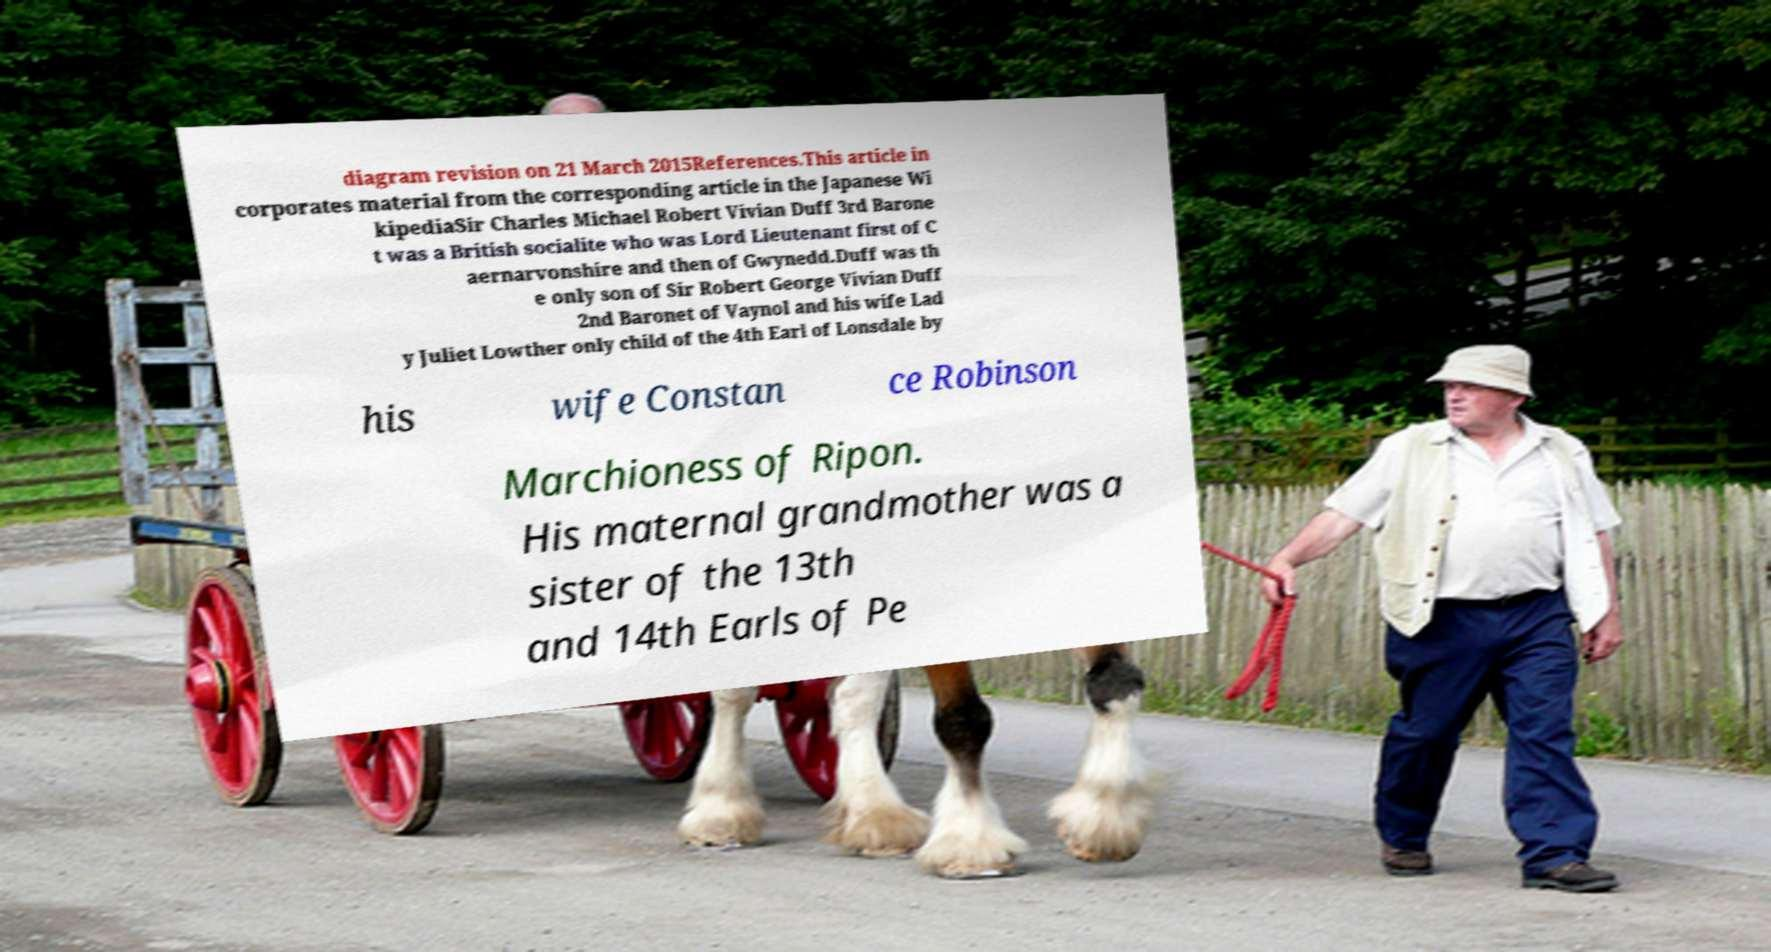I need the written content from this picture converted into text. Can you do that? diagram revision on 21 March 2015References.This article in corporates material from the corresponding article in the Japanese Wi kipediaSir Charles Michael Robert Vivian Duff 3rd Barone t was a British socialite who was Lord Lieutenant first of C aernarvonshire and then of Gwynedd.Duff was th e only son of Sir Robert George Vivian Duff 2nd Baronet of Vaynol and his wife Lad y Juliet Lowther only child of the 4th Earl of Lonsdale by his wife Constan ce Robinson Marchioness of Ripon. His maternal grandmother was a sister of the 13th and 14th Earls of Pe 